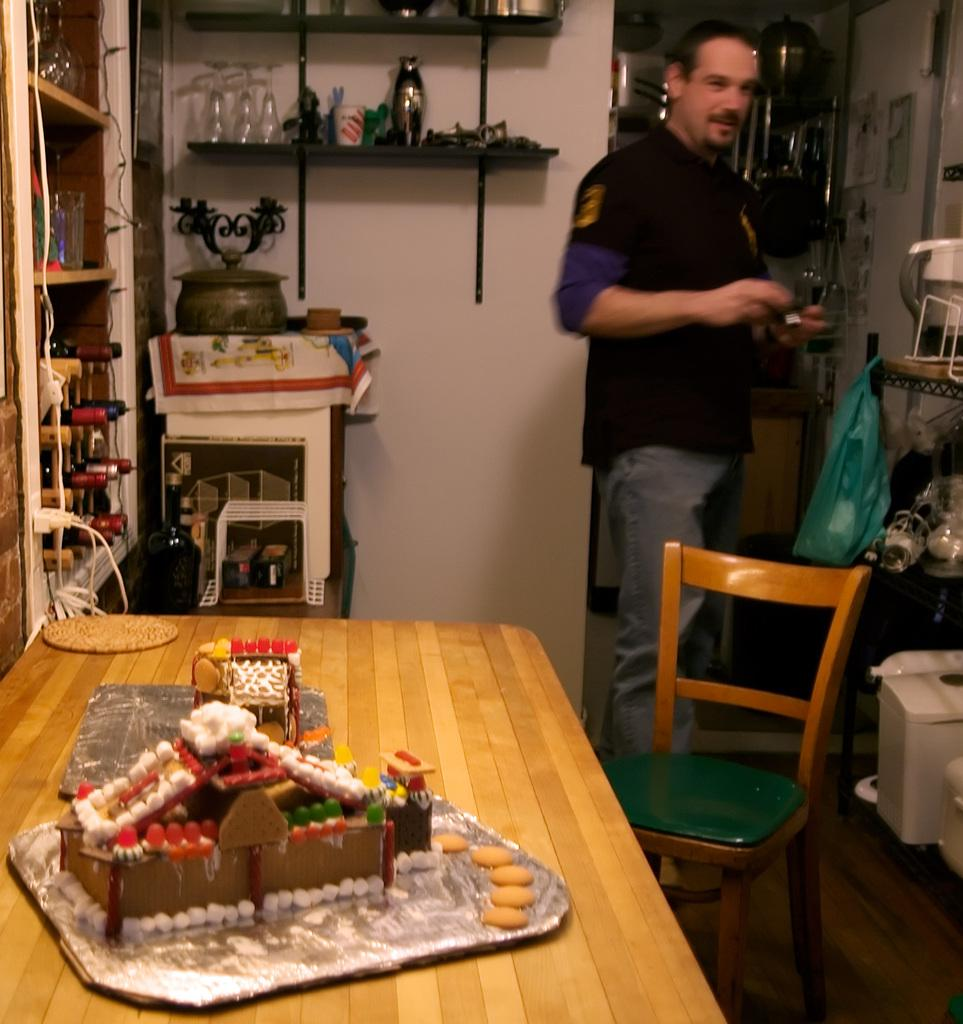What is on the table in the image? There are objects placed on the table in the image. Can you describe the person in the image? There is a person standing in the right corner of the image. What type of pail is being used by the person in the image? There is no pail present in the image; the person is standing in the right corner. How many chairs are visible in the scene? There is no scene mentioned in the facts, and no chairs are visible in the image. 